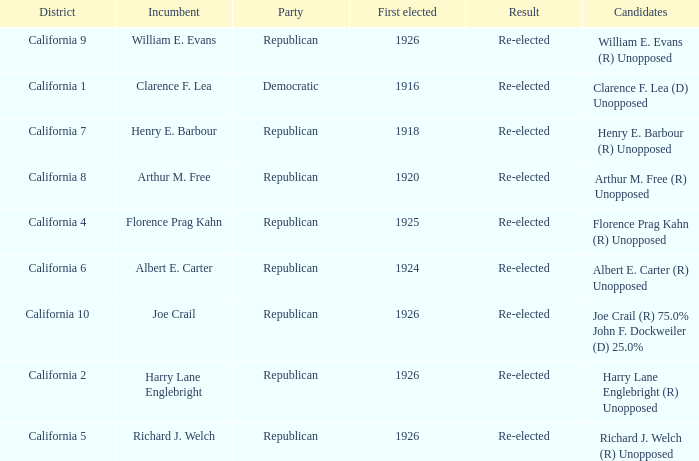In what district does harry lane englebright (r) run unopposed? California 2. 